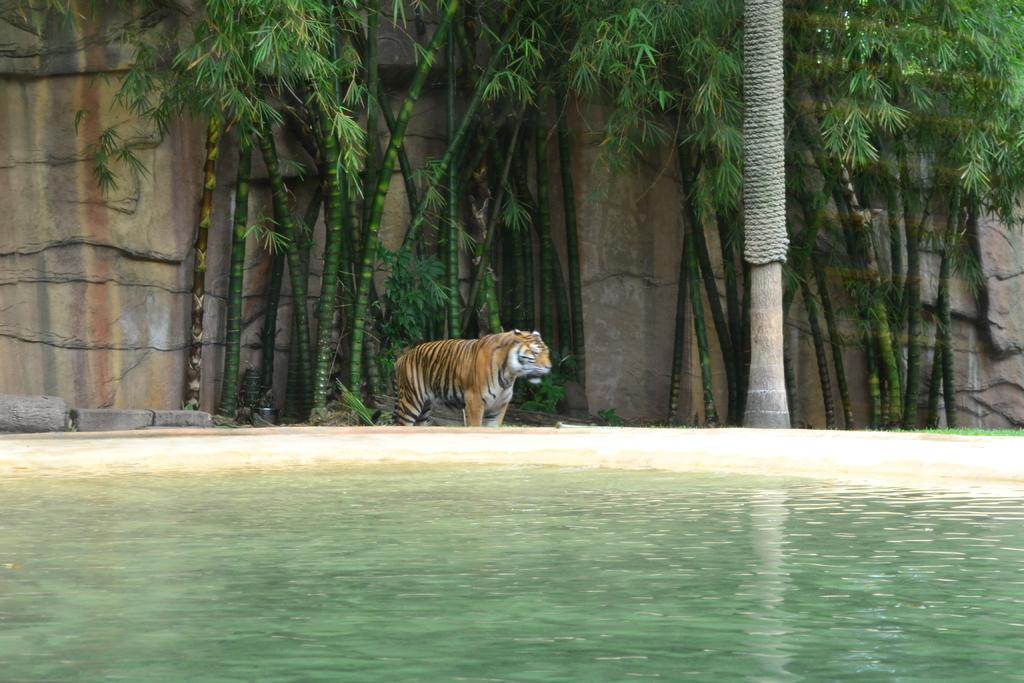Describe this image in one or two sentences. In this picture I can see tiger is standing on the ground. Here I can see water. In the background I can see trees and a wall. 